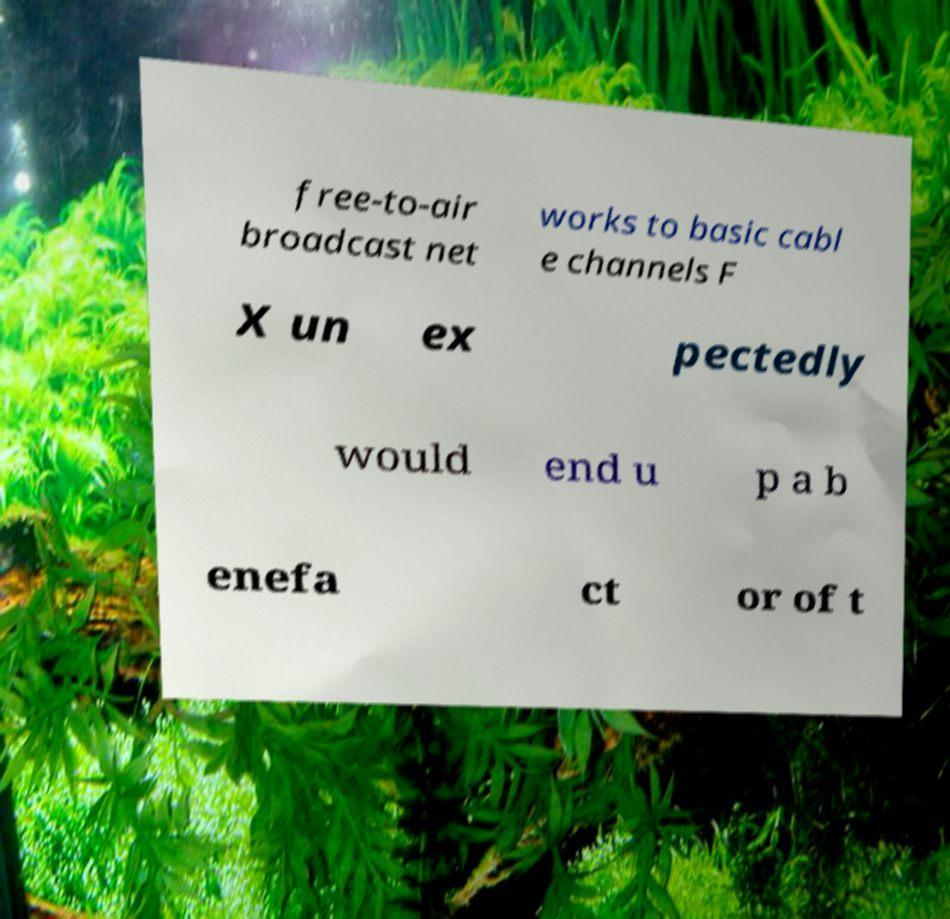There's text embedded in this image that I need extracted. Can you transcribe it verbatim? free-to-air broadcast net works to basic cabl e channels F X un ex pectedly would end u p a b enefa ct or of t 